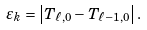Convert formula to latex. <formula><loc_0><loc_0><loc_500><loc_500>\varepsilon _ { k } = \left | T _ { \ell , 0 } - T _ { \ell - 1 , 0 } \right | .</formula> 